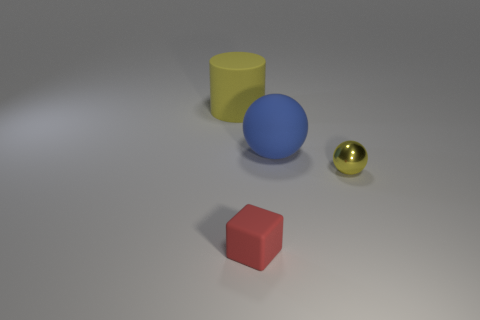Add 4 tiny cyan matte spheres. How many objects exist? 8 Subtract all cylinders. How many objects are left? 3 Subtract all big yellow matte things. Subtract all metallic things. How many objects are left? 2 Add 1 shiny balls. How many shiny balls are left? 2 Add 2 yellow spheres. How many yellow spheres exist? 3 Subtract 0 green spheres. How many objects are left? 4 